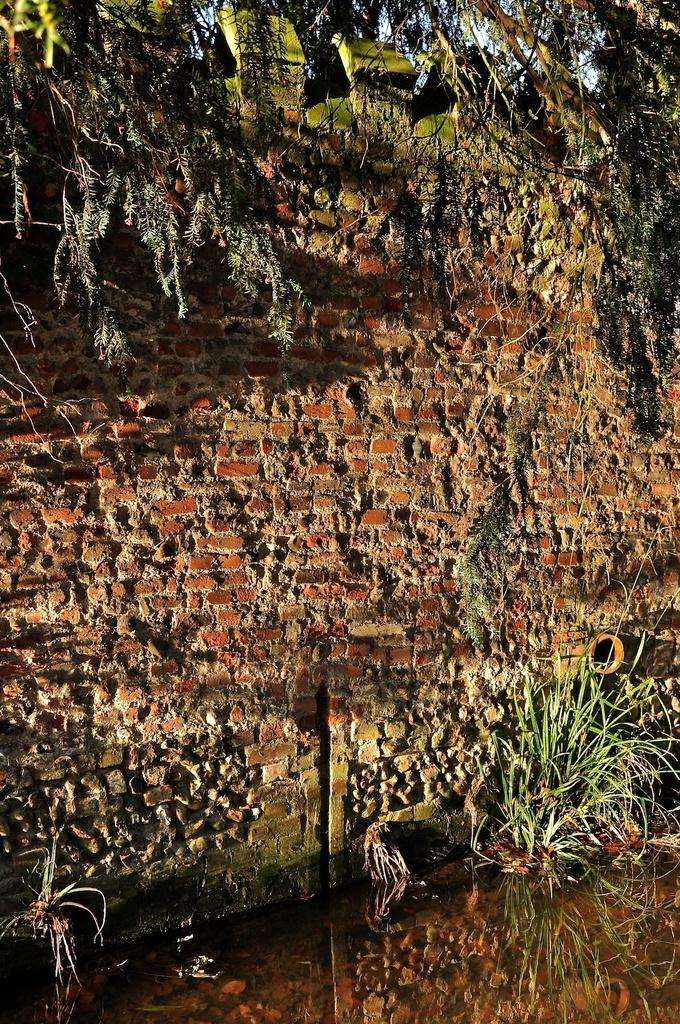What type of walls are visible in the middle of the image? There are red color brick walls in the middle of the image. What can be seen in front of the bottom side of the image? Small plants are present in front of the bottom side of the image. Is there a store visible in the image? No, there is no store present in the image. 